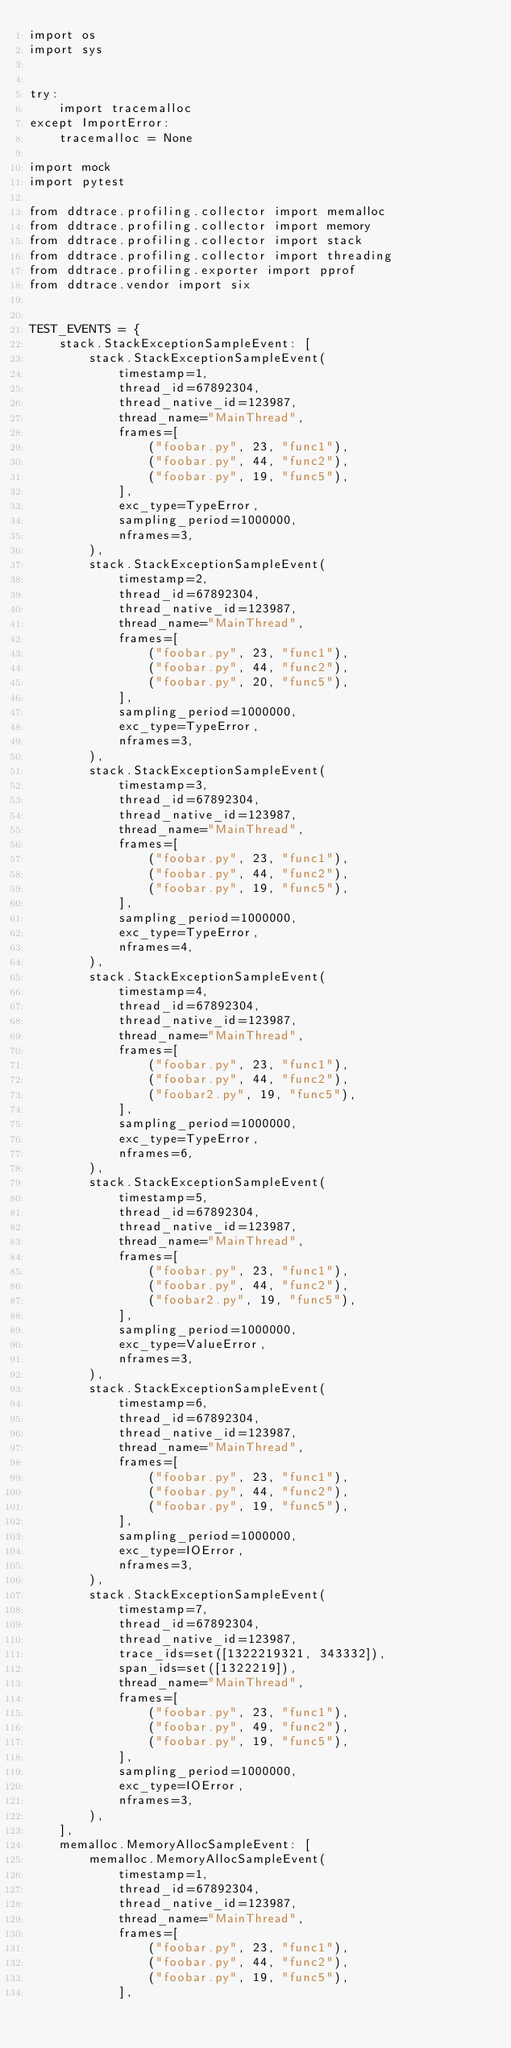Convert code to text. <code><loc_0><loc_0><loc_500><loc_500><_Python_>import os
import sys


try:
    import tracemalloc
except ImportError:
    tracemalloc = None

import mock
import pytest

from ddtrace.profiling.collector import memalloc
from ddtrace.profiling.collector import memory
from ddtrace.profiling.collector import stack
from ddtrace.profiling.collector import threading
from ddtrace.profiling.exporter import pprof
from ddtrace.vendor import six


TEST_EVENTS = {
    stack.StackExceptionSampleEvent: [
        stack.StackExceptionSampleEvent(
            timestamp=1,
            thread_id=67892304,
            thread_native_id=123987,
            thread_name="MainThread",
            frames=[
                ("foobar.py", 23, "func1"),
                ("foobar.py", 44, "func2"),
                ("foobar.py", 19, "func5"),
            ],
            exc_type=TypeError,
            sampling_period=1000000,
            nframes=3,
        ),
        stack.StackExceptionSampleEvent(
            timestamp=2,
            thread_id=67892304,
            thread_native_id=123987,
            thread_name="MainThread",
            frames=[
                ("foobar.py", 23, "func1"),
                ("foobar.py", 44, "func2"),
                ("foobar.py", 20, "func5"),
            ],
            sampling_period=1000000,
            exc_type=TypeError,
            nframes=3,
        ),
        stack.StackExceptionSampleEvent(
            timestamp=3,
            thread_id=67892304,
            thread_native_id=123987,
            thread_name="MainThread",
            frames=[
                ("foobar.py", 23, "func1"),
                ("foobar.py", 44, "func2"),
                ("foobar.py", 19, "func5"),
            ],
            sampling_period=1000000,
            exc_type=TypeError,
            nframes=4,
        ),
        stack.StackExceptionSampleEvent(
            timestamp=4,
            thread_id=67892304,
            thread_native_id=123987,
            thread_name="MainThread",
            frames=[
                ("foobar.py", 23, "func1"),
                ("foobar.py", 44, "func2"),
                ("foobar2.py", 19, "func5"),
            ],
            sampling_period=1000000,
            exc_type=TypeError,
            nframes=6,
        ),
        stack.StackExceptionSampleEvent(
            timestamp=5,
            thread_id=67892304,
            thread_native_id=123987,
            thread_name="MainThread",
            frames=[
                ("foobar.py", 23, "func1"),
                ("foobar.py", 44, "func2"),
                ("foobar2.py", 19, "func5"),
            ],
            sampling_period=1000000,
            exc_type=ValueError,
            nframes=3,
        ),
        stack.StackExceptionSampleEvent(
            timestamp=6,
            thread_id=67892304,
            thread_native_id=123987,
            thread_name="MainThread",
            frames=[
                ("foobar.py", 23, "func1"),
                ("foobar.py", 44, "func2"),
                ("foobar.py", 19, "func5"),
            ],
            sampling_period=1000000,
            exc_type=IOError,
            nframes=3,
        ),
        stack.StackExceptionSampleEvent(
            timestamp=7,
            thread_id=67892304,
            thread_native_id=123987,
            trace_ids=set([1322219321, 343332]),
            span_ids=set([1322219]),
            thread_name="MainThread",
            frames=[
                ("foobar.py", 23, "func1"),
                ("foobar.py", 49, "func2"),
                ("foobar.py", 19, "func5"),
            ],
            sampling_period=1000000,
            exc_type=IOError,
            nframes=3,
        ),
    ],
    memalloc.MemoryAllocSampleEvent: [
        memalloc.MemoryAllocSampleEvent(
            timestamp=1,
            thread_id=67892304,
            thread_native_id=123987,
            thread_name="MainThread",
            frames=[
                ("foobar.py", 23, "func1"),
                ("foobar.py", 44, "func2"),
                ("foobar.py", 19, "func5"),
            ],</code> 